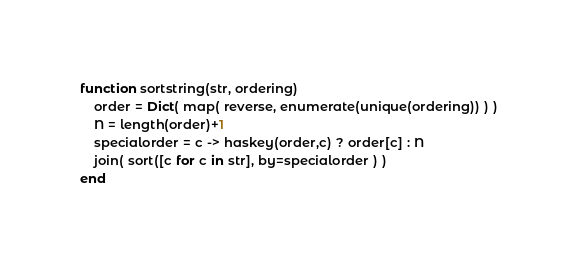Convert code to text. <code><loc_0><loc_0><loc_500><loc_500><_Julia_>function sortstring(str, ordering)
    order = Dict( map( reverse, enumerate(unique(ordering)) ) )
    N = length(order)+1
    specialorder = c -> haskey(order,c) ? order[c] : N
    join( sort([c for c in str], by=specialorder ) )
end</code> 